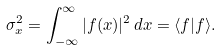<formula> <loc_0><loc_0><loc_500><loc_500>\sigma _ { x } ^ { 2 } = \int _ { - \infty } ^ { \infty } | f ( x ) | ^ { 2 } \, d x = \langle f | f \rangle .</formula> 